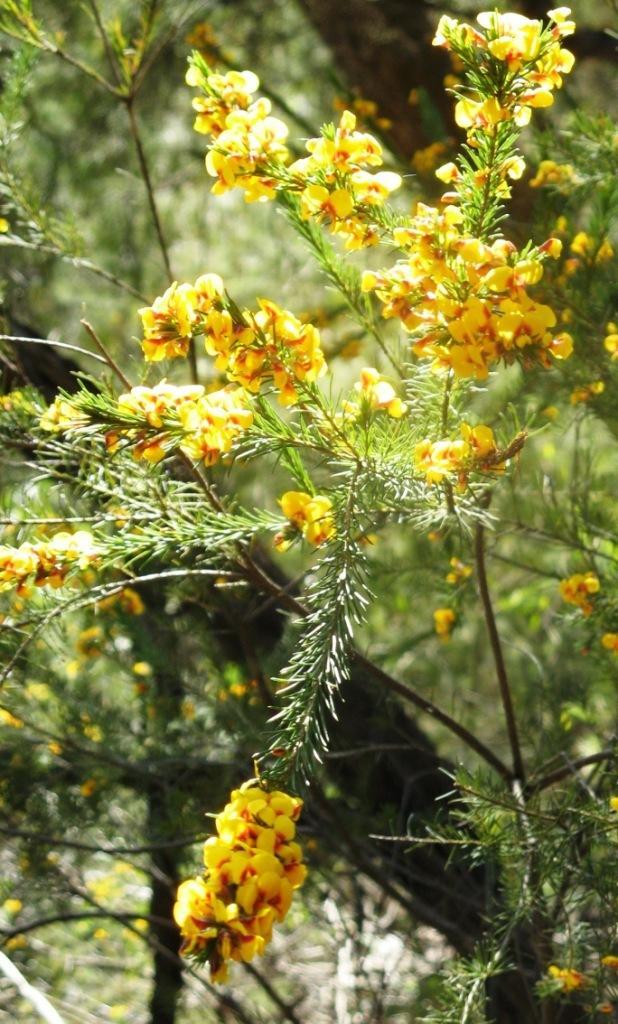Could you give a brief overview of what you see in this image? In this image there are plants with yellow flowers, and there is blur background. 